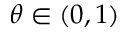<formula> <loc_0><loc_0><loc_500><loc_500>\theta \in ( 0 , 1 )</formula> 